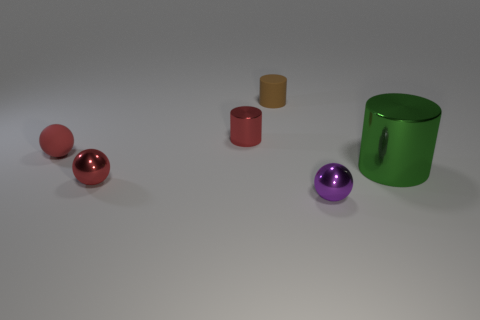Can you describe the textures of the different objects and how they might feel to touch? Certainly! The spheres and the large green cylinder have surfaces that appear to be very smooth and reflective, suggesting a polished or glossy material that might feel slick to the touch. The small cylinders, in contrast, seem to have matte-finished surfaces, which would likely feel less smooth and more diffuse. They might give a sensation of a material such as stone or brushed metal. 